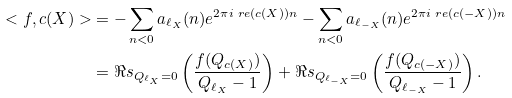<formula> <loc_0><loc_0><loc_500><loc_500>< f , c ( X ) > & = - \sum _ { n < 0 } a _ { \ell _ { X } } ( n ) e ^ { 2 \pi i \ r e ( c ( X ) ) n } - \sum _ { n < 0 } a _ { \ell _ { - X } } ( n ) e ^ { 2 \pi i \ r e ( c ( - X ) ) n } \\ & = \Re s _ { Q _ { \ell _ { X } } = 0 } \left ( \frac { f ( Q _ { c ( X ) } ) } { Q _ { \ell _ { X } } - 1 } \right ) + \Re s _ { Q _ { \ell _ { - X } } = 0 } \left ( \frac { f ( Q _ { c ( - X ) } ) } { Q _ { \ell _ { - X } } - 1 } \right ) .</formula> 